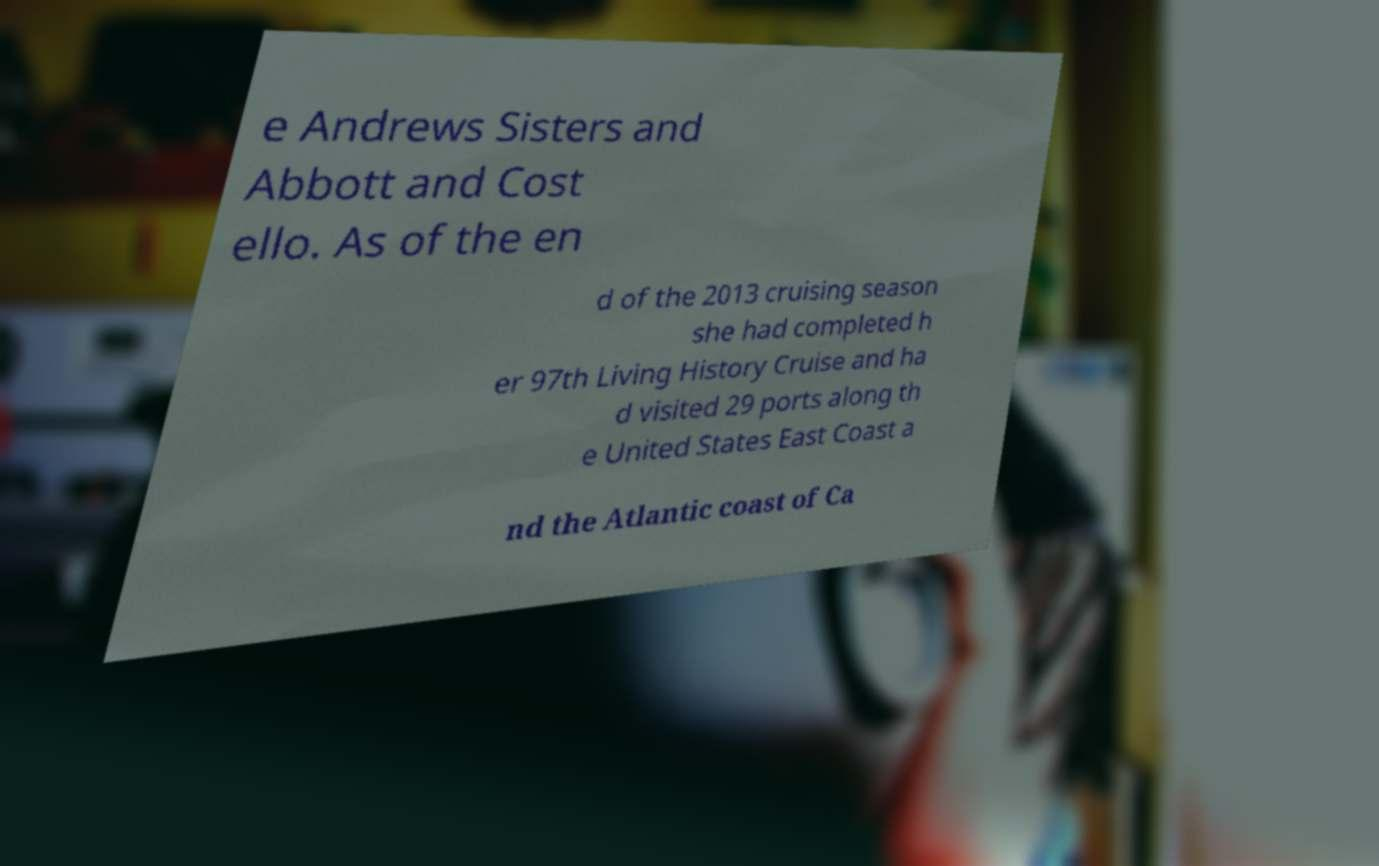What messages or text are displayed in this image? I need them in a readable, typed format. e Andrews Sisters and Abbott and Cost ello. As of the en d of the 2013 cruising season she had completed h er 97th Living History Cruise and ha d visited 29 ports along th e United States East Coast a nd the Atlantic coast of Ca 